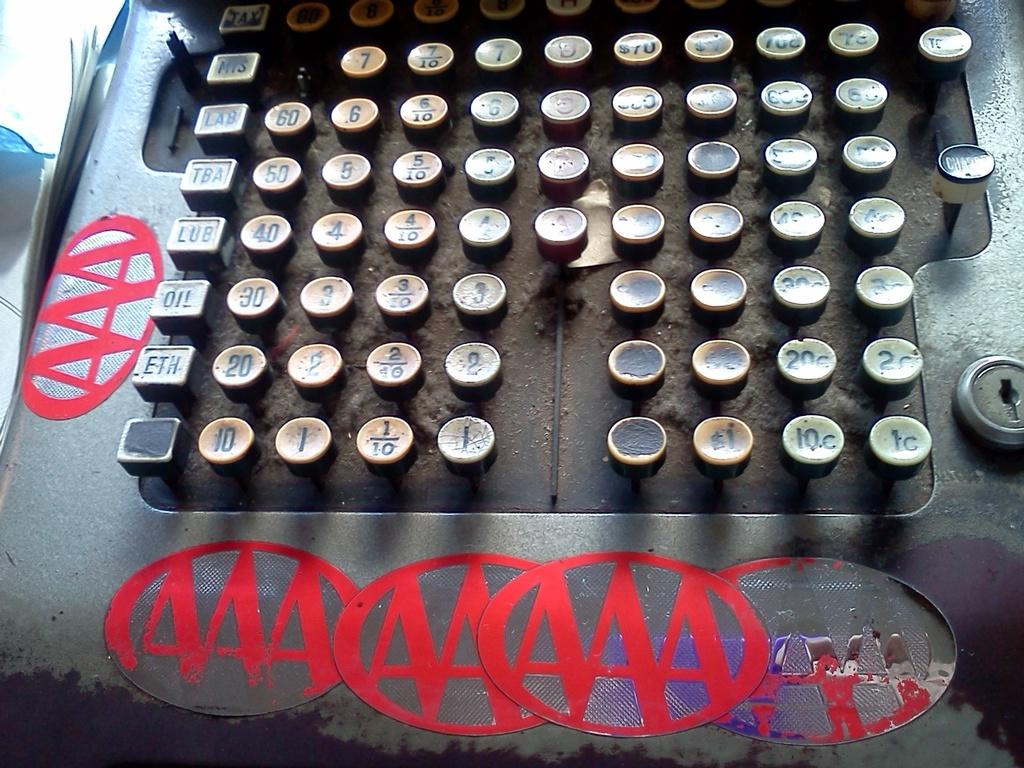<image>
Offer a succinct explanation of the picture presented. An old school cash register that is triple AAA stamps on it. 